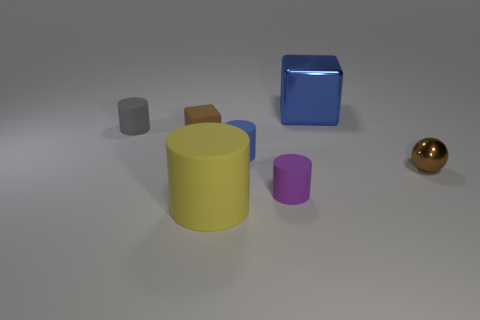What is the shape of the large object that is to the right of the tiny cylinder in front of the small brown metallic thing?
Your answer should be compact. Cube. What is the color of the large thing that is the same material as the brown block?
Keep it short and to the point. Yellow. Is the color of the shiny sphere the same as the tiny block?
Your answer should be compact. Yes. There is a blue rubber object that is the same size as the gray rubber cylinder; what shape is it?
Your answer should be very brief. Cylinder. How big is the yellow matte object?
Give a very brief answer. Large. There is a cube that is left of the big yellow rubber thing; does it have the same size as the brown object right of the large metal thing?
Provide a short and direct response. Yes. There is a rubber cylinder behind the small brown object that is on the left side of the ball; what is its color?
Ensure brevity in your answer.  Gray. What is the material of the purple cylinder that is the same size as the blue cylinder?
Offer a terse response. Rubber. How many matte objects are either red blocks or blue cylinders?
Your answer should be compact. 1. There is a thing that is both behind the tiny brown rubber block and left of the big cube; what is its color?
Offer a terse response. Gray. 